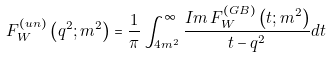<formula> <loc_0><loc_0><loc_500><loc_500>F _ { W } ^ { ( u n ) } \left ( q ^ { 2 } ; m ^ { 2 } \right ) = \frac { 1 } { \pi } \int _ { 4 m ^ { 2 } } ^ { \infty } \frac { I m \, F _ { W } ^ { ( G B ) } \left ( t ; m ^ { 2 } \right ) } { t - q ^ { 2 } } d t</formula> 